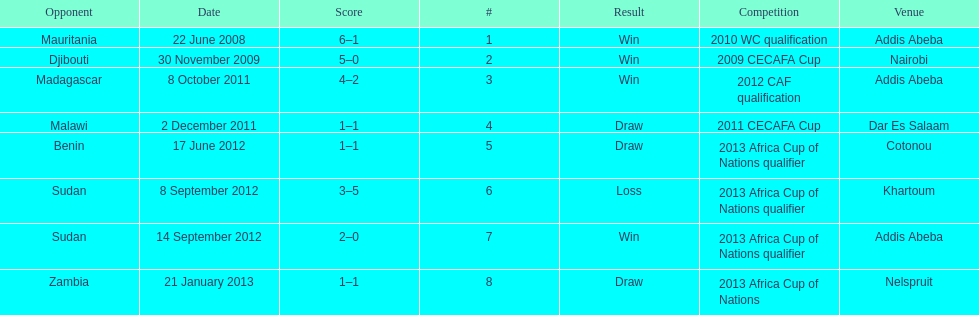How long in years down this table cover? 5. 